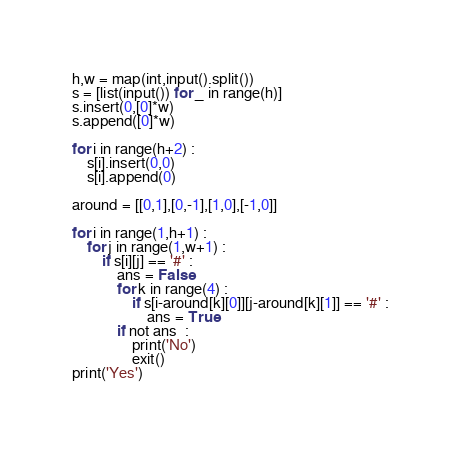Convert code to text. <code><loc_0><loc_0><loc_500><loc_500><_Python_>h,w = map(int,input().split())
s = [list(input()) for _ in range(h)]
s.insert(0,[0]*w)
s.append([0]*w)

for i in range(h+2) :
    s[i].insert(0,0)
    s[i].append(0)

around = [[0,1],[0,-1],[1,0],[-1,0]]

for i in range(1,h+1) :
    for j in range(1,w+1) :
        if s[i][j] == '#' :
            ans = False
            for k in range(4) :
                if s[i-around[k][0]][j-around[k][1]] == '#' :
                    ans = True
            if not ans  :
                print('No')
                exit()
print('Yes')</code> 